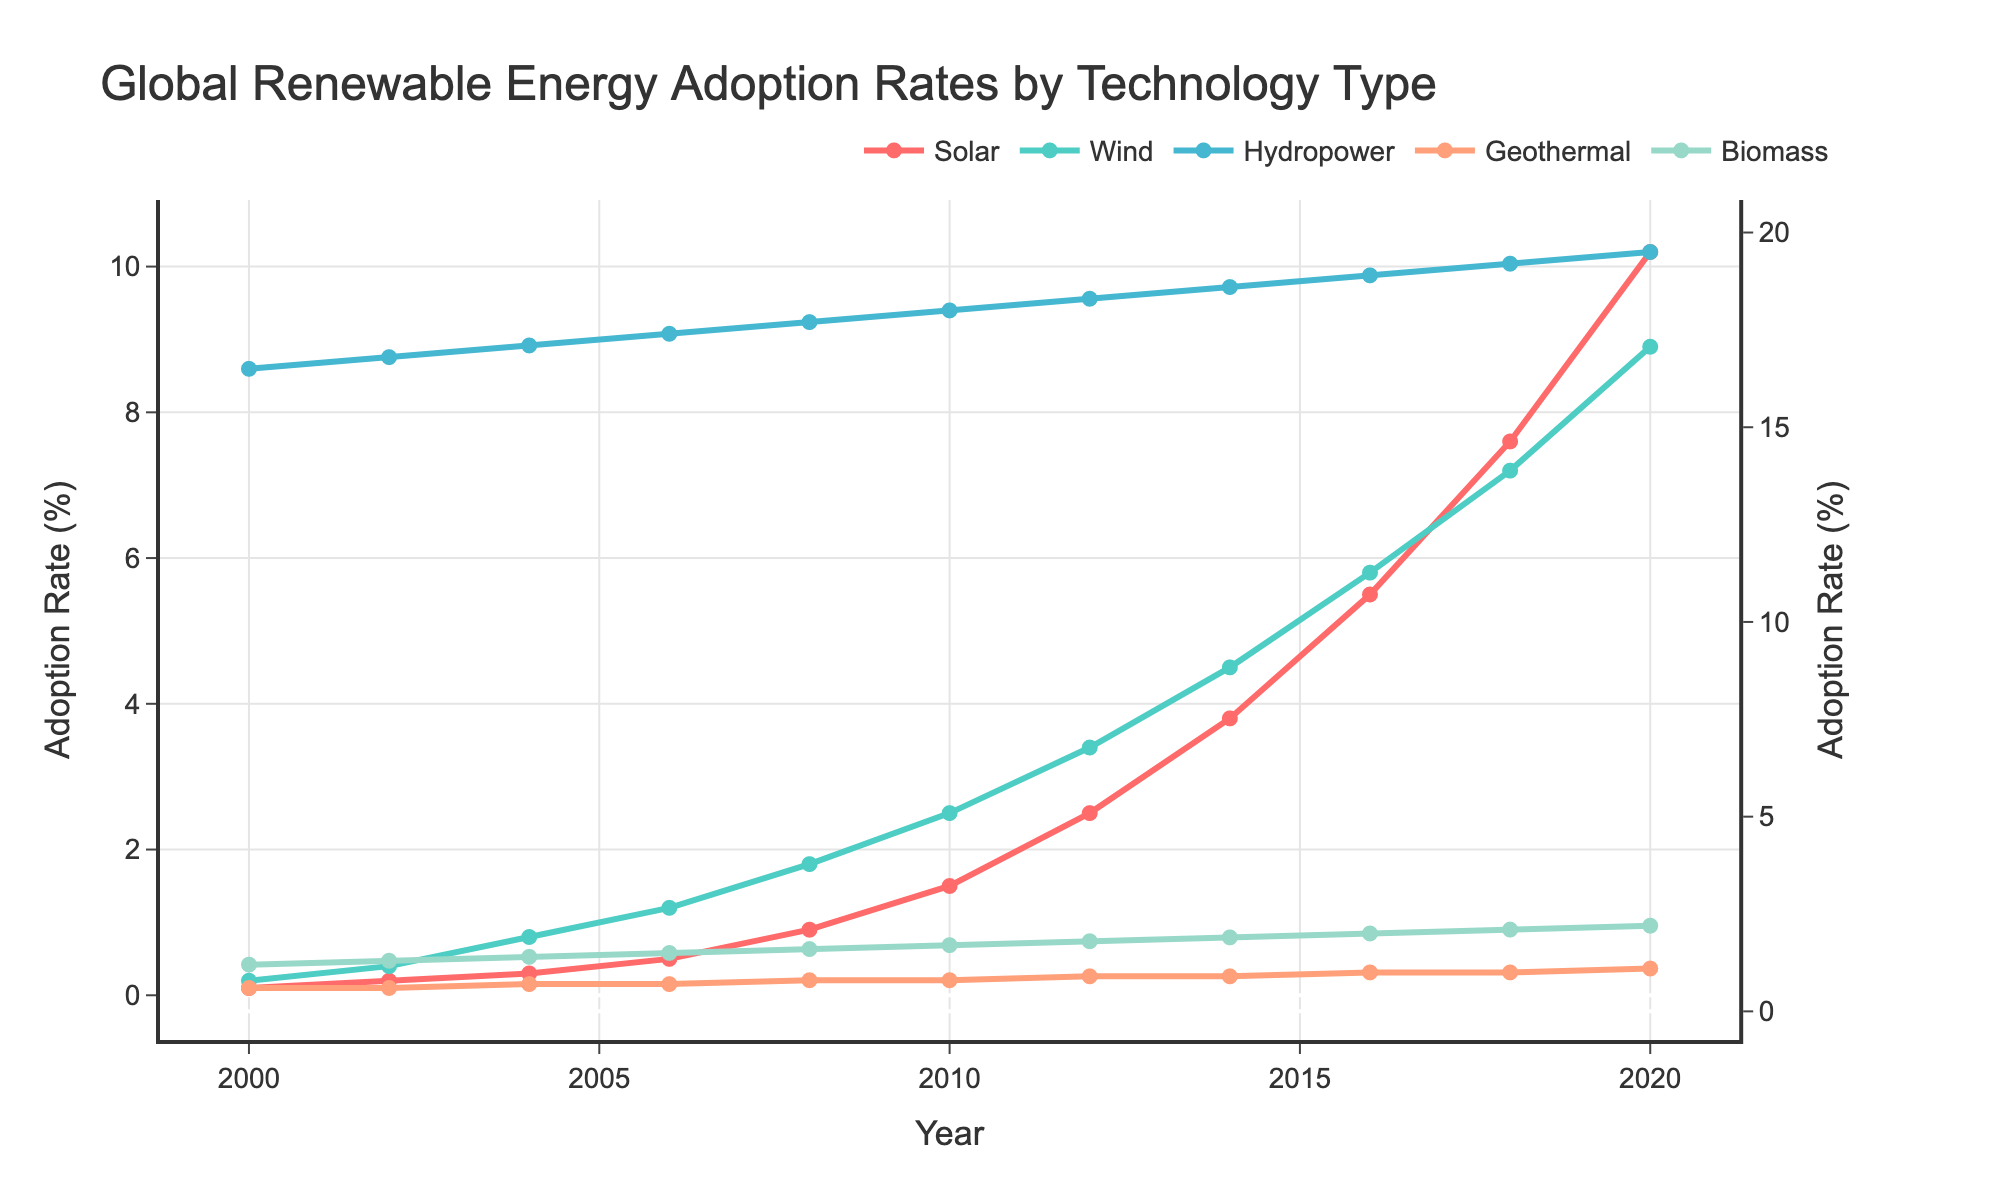what technology had the highest adoption rate in 2000? Look for the year 2000 on the x-axis and compare all data lines. Hydropower has the highest point around 16.5% compared to other technologies.
Answer: Hydropower Which technology showed the most significant growth from 2000 to 2020? Calculate the difference in adoption rates for each technology between 2000 and 2020. Solar went from 0.1% to 10.2%, the most substantial increase among all technologies.
Answer: Solar What's the combined adoption rate of Solar and Wind in 2010? Identify the adoption rates for Solar and Wind in 2010 and sum them: Solar (1.5%) + Wind (2.5%) = 4.0%.
Answer: 4.0% Did any technology's adoption rate decline over the years? Examine the trends for each technology from 2000 to 2020. All technologies show steady or increasing trends, with no declines.
Answer: No Which technology had nearly constant growth in adoption rate over the years? Observe the steadiness of the line. Biomass shows a consistent upward trend with nearly equal increments over time.
Answer: Biomass In which year did Wind energy adoption surpass 5%? Follow the Wind energy line and identify the year when it crosses the 5% mark. It crosses in 2016.
Answer: 2016 How many technologies had an adoption rate above 5% in 2020? Identify the data point for the year 2020 and count peaks above 5%: Solar, Wind, and Hydropower.
Answer: 3 What is the difference in adoption rates between Solar and Geothermal in 2018? Locate the rates for Solar (7.6%) and Geothermal (1.0%) in 2018, then subtract: 7.6% - 1.0% = 6.6%.
Answer: 6.6% What visual feature helps distinguish Solar and Wind lines? Notice the different colors for Solar (red) and Wind (green). Their colors and line thickness help differentiate them.
Answer: Colors By how much did the biomass adoption rate grow between 2000 and 2012? Identify rates in 2000 (1.2%) and 2012 (1.8%), then calculate the difference: 1.8% - 1.2% = 0.6%.
Answer: 0.6% 